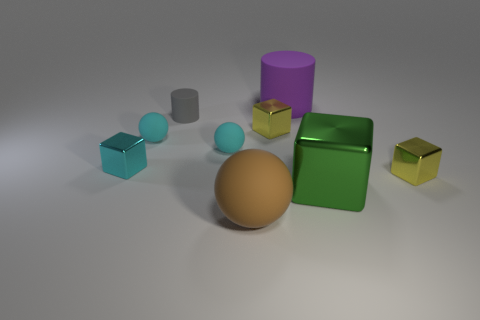There is a metal block that is the same size as the purple cylinder; what is its color? green 